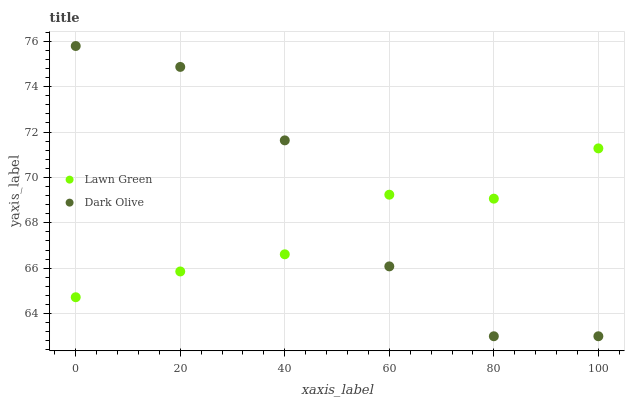Does Lawn Green have the minimum area under the curve?
Answer yes or no. Yes. Does Dark Olive have the maximum area under the curve?
Answer yes or no. Yes. Does Dark Olive have the minimum area under the curve?
Answer yes or no. No. Is Lawn Green the smoothest?
Answer yes or no. Yes. Is Dark Olive the roughest?
Answer yes or no. Yes. Is Dark Olive the smoothest?
Answer yes or no. No. Does Dark Olive have the lowest value?
Answer yes or no. Yes. Does Dark Olive have the highest value?
Answer yes or no. Yes. Does Lawn Green intersect Dark Olive?
Answer yes or no. Yes. Is Lawn Green less than Dark Olive?
Answer yes or no. No. Is Lawn Green greater than Dark Olive?
Answer yes or no. No. 